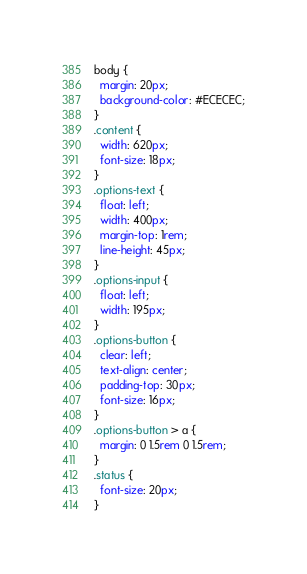<code> <loc_0><loc_0><loc_500><loc_500><_CSS_>body {
  margin: 20px;
  background-color: #ECECEC;
}
.content {
  width: 620px;
  font-size: 18px;
}
.options-text {
  float: left;
  width: 400px;
  margin-top: 1rem;
  line-height: 45px;
}
.options-input {
  float: left;
  width: 195px;
}
.options-button {
  clear: left;
  text-align: center;
  padding-top: 30px;
  font-size: 16px;
}
.options-button > a {
  margin: 0 1.5rem 0 1.5rem;
}
.status {
  font-size: 20px;
}
</code> 